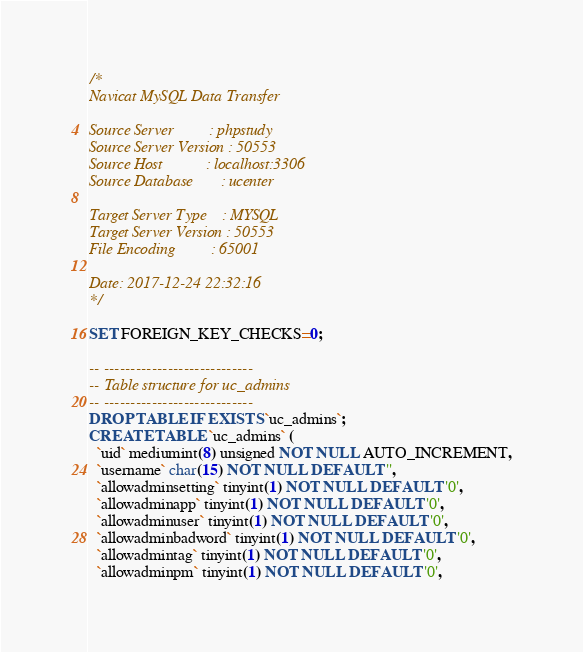Convert code to text. <code><loc_0><loc_0><loc_500><loc_500><_SQL_>/*
Navicat MySQL Data Transfer

Source Server         : phpstudy
Source Server Version : 50553
Source Host           : localhost:3306
Source Database       : ucenter

Target Server Type    : MYSQL
Target Server Version : 50553
File Encoding         : 65001

Date: 2017-12-24 22:32:16
*/

SET FOREIGN_KEY_CHECKS=0;

-- ----------------------------
-- Table structure for uc_admins
-- ----------------------------
DROP TABLE IF EXISTS `uc_admins`;
CREATE TABLE `uc_admins` (
  `uid` mediumint(8) unsigned NOT NULL AUTO_INCREMENT,
  `username` char(15) NOT NULL DEFAULT '',
  `allowadminsetting` tinyint(1) NOT NULL DEFAULT '0',
  `allowadminapp` tinyint(1) NOT NULL DEFAULT '0',
  `allowadminuser` tinyint(1) NOT NULL DEFAULT '0',
  `allowadminbadword` tinyint(1) NOT NULL DEFAULT '0',
  `allowadmintag` tinyint(1) NOT NULL DEFAULT '0',
  `allowadminpm` tinyint(1) NOT NULL DEFAULT '0',</code> 